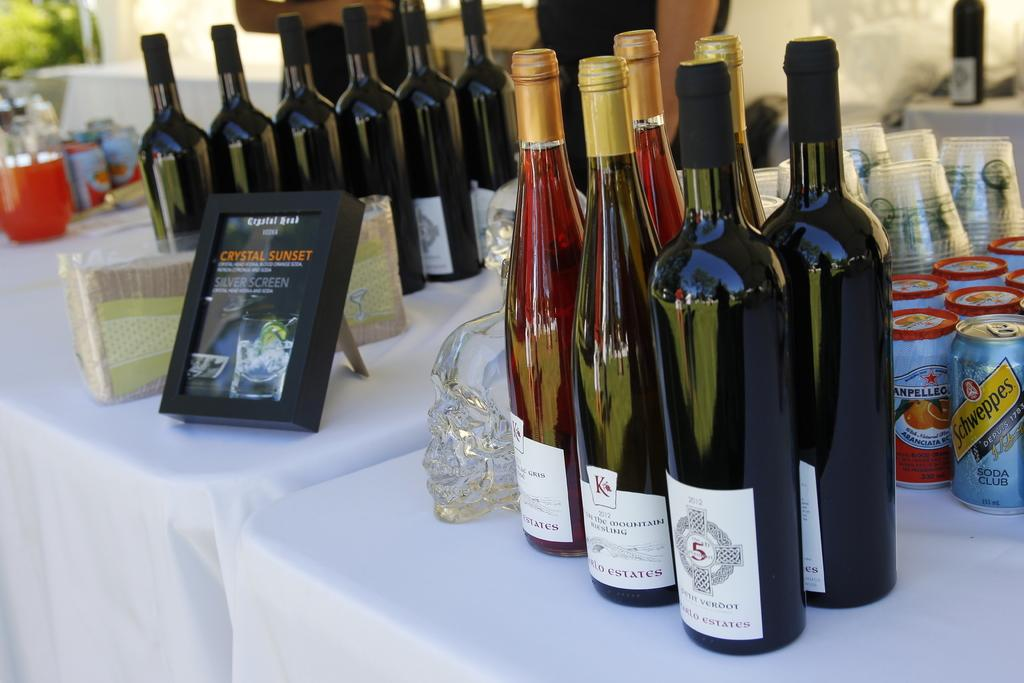Provide a one-sentence caption for the provided image. tables with white cloth and framed sign with crystal sunset on it and several bottles of wine on it and can schweppe's club soda behind wine. 